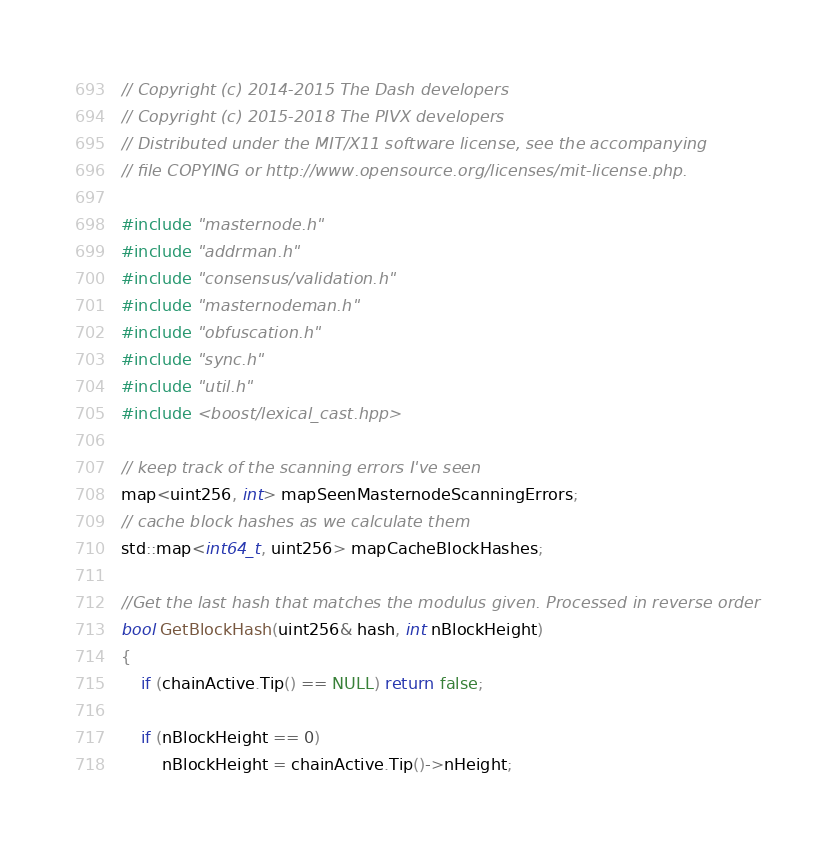Convert code to text. <code><loc_0><loc_0><loc_500><loc_500><_C++_>// Copyright (c) 2014-2015 The Dash developers
// Copyright (c) 2015-2018 The PIVX developers
// Distributed under the MIT/X11 software license, see the accompanying
// file COPYING or http://www.opensource.org/licenses/mit-license.php.

#include "masternode.h"
#include "addrman.h"
#include "consensus/validation.h"
#include "masternodeman.h"
#include "obfuscation.h"
#include "sync.h"
#include "util.h"
#include <boost/lexical_cast.hpp>

// keep track of the scanning errors I've seen
map<uint256, int> mapSeenMasternodeScanningErrors;
// cache block hashes as we calculate them
std::map<int64_t, uint256> mapCacheBlockHashes;

//Get the last hash that matches the modulus given. Processed in reverse order
bool GetBlockHash(uint256& hash, int nBlockHeight)
{
    if (chainActive.Tip() == NULL) return false;

    if (nBlockHeight == 0)
        nBlockHeight = chainActive.Tip()->nHeight;
</code> 